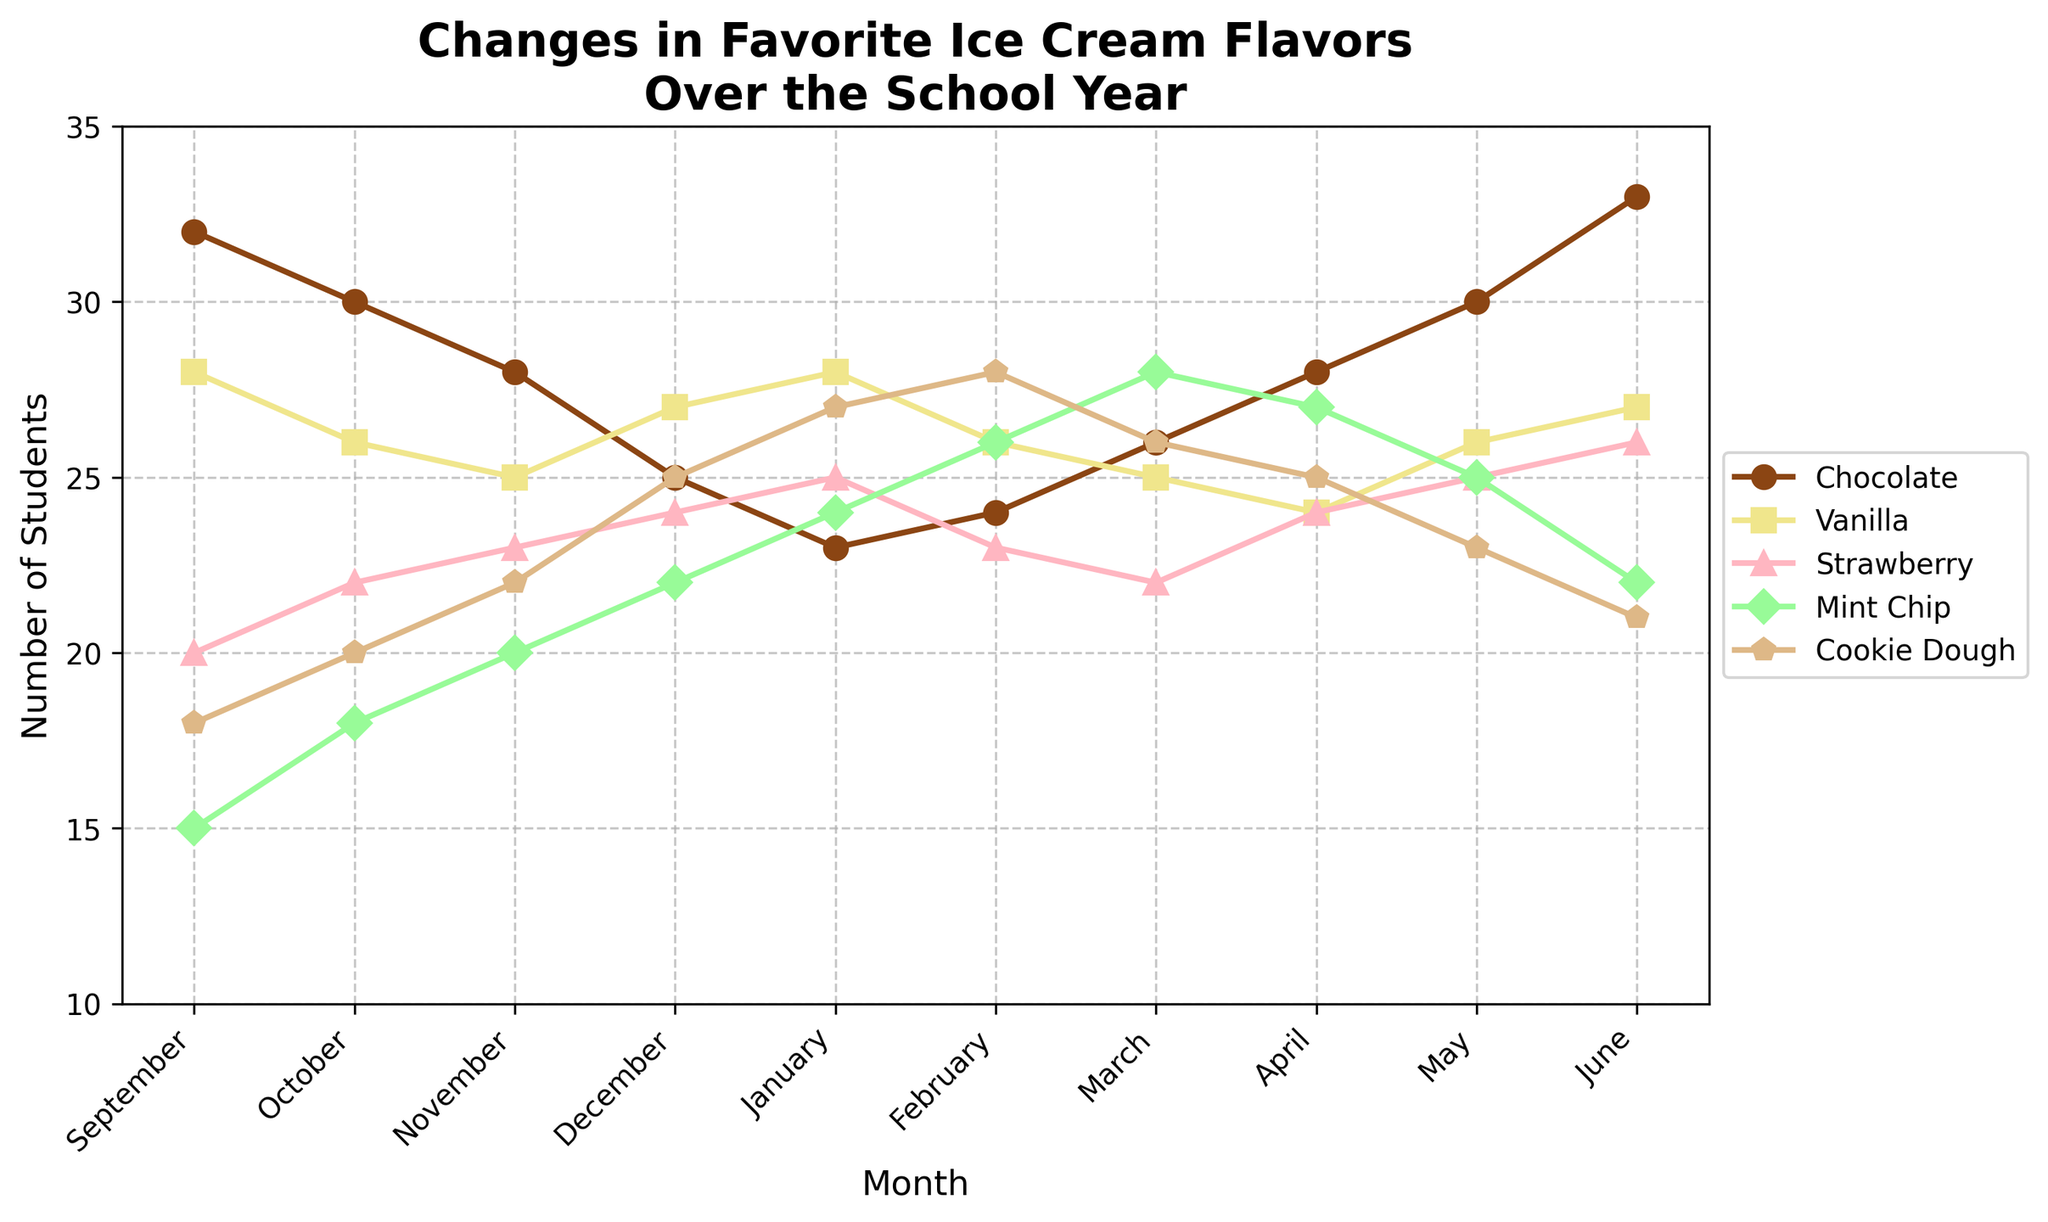Which month has the highest number of students who prefer Chocolate? Look for the highest point on the Chocolate line on the chart.
Answer: June Which ice cream flavor was the least popular in September? Check the lowest point among all lines in September.
Answer: Mint Chip How does the preference for Vanilla change from October to December? Look at the Vanilla line's value at October and compare it to December. Vanilla starts at 26 in October and increases to 27 by December.
Answer: Increases What is the difference in the number of students who prefer Cookie Dough between January and June? Subtract the number of students in January from June. 21 (June) - 27 (January) = -6
Answer: -6 Which month shows the highest number of students preferring Mint Chip? Find the highest point on the Mint Chip line.
Answer: March How do preferences for Strawberry and Vanilla compare in December? Look at the values of Strawberry and Vanilla in December and compare. Strawberry has 24, Vanilla has 27.
Answer: Vanilla is more popular What's the average number of students who preferred Chocolate in September, October, and November? Add the numbers for September, October, and November, then divide by 3. (32 + 30 + 28) / 3 = 30
Answer: 30 Which two months show the same number of students preferring Mint Chip? Look for two points on the Mint Chip line that are at the same height.
Answer: April and May By how much did the preference for Cookie Dough change from December to February? Subtract the number in December from that in February. 28 (February) - 25 (December) = 3
Answer: 3 Which flavor had the most consistent number of students over the school year? Observe which line is the most stable and has the least variation.
Answer: Vanilla 